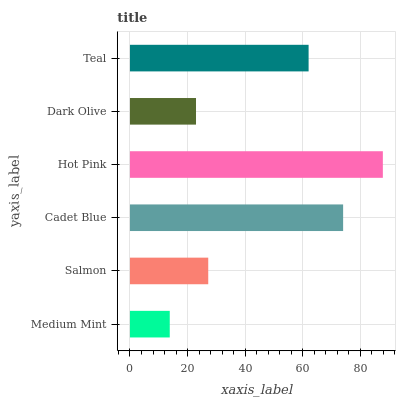Is Medium Mint the minimum?
Answer yes or no. Yes. Is Hot Pink the maximum?
Answer yes or no. Yes. Is Salmon the minimum?
Answer yes or no. No. Is Salmon the maximum?
Answer yes or no. No. Is Salmon greater than Medium Mint?
Answer yes or no. Yes. Is Medium Mint less than Salmon?
Answer yes or no. Yes. Is Medium Mint greater than Salmon?
Answer yes or no. No. Is Salmon less than Medium Mint?
Answer yes or no. No. Is Teal the high median?
Answer yes or no. Yes. Is Salmon the low median?
Answer yes or no. Yes. Is Medium Mint the high median?
Answer yes or no. No. Is Medium Mint the low median?
Answer yes or no. No. 